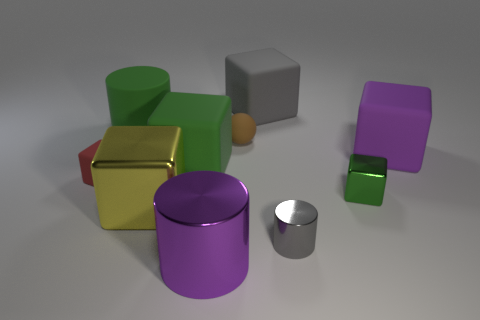What is the cylinder that is in front of the tiny metallic cylinder made of?
Your response must be concise. Metal. Are there the same number of gray things that are left of the matte sphere and green cylinders that are in front of the large metallic block?
Ensure brevity in your answer.  Yes. Is the size of the cube that is left of the large green matte cylinder the same as the green cube left of the gray matte object?
Keep it short and to the point. No. What number of matte blocks are the same color as the small shiny cylinder?
Your answer should be very brief. 1. There is a object that is the same color as the big shiny cylinder; what is it made of?
Offer a terse response. Rubber. Are there more big objects that are to the left of the green cylinder than tiny gray metallic cylinders?
Make the answer very short. No. Is the shape of the small green thing the same as the small gray object?
Keep it short and to the point. No. What number of green cubes have the same material as the brown ball?
Offer a very short reply. 1. What is the size of the red object that is the same shape as the green metallic thing?
Your answer should be very brief. Small. Do the purple shiny object and the gray rubber cube have the same size?
Offer a terse response. Yes. 